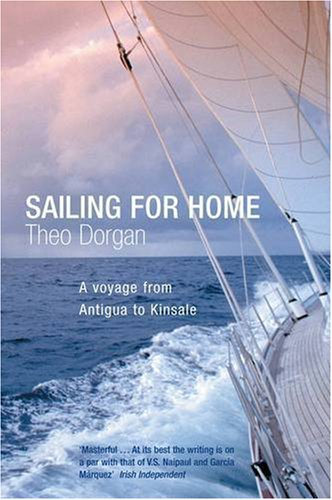What is the genre of this book? The genre of the book is travel, focusing on personal experiences and the adventures encountered during a sea voyage. 